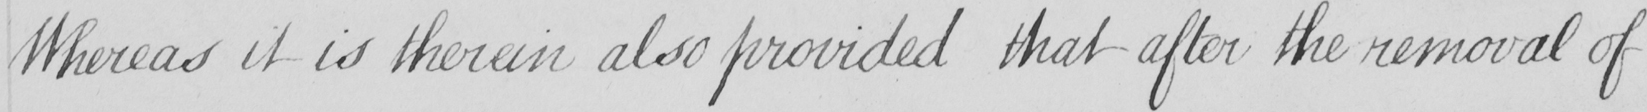Transcribe the text shown in this historical manuscript line. Whereas it is therein also provided that after the removal of 